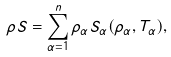Convert formula to latex. <formula><loc_0><loc_0><loc_500><loc_500>\rho S = \sum _ { \alpha = 1 } ^ { n } \rho _ { \alpha } S _ { \alpha } ( \rho _ { \alpha } , T _ { \alpha } ) ,</formula> 